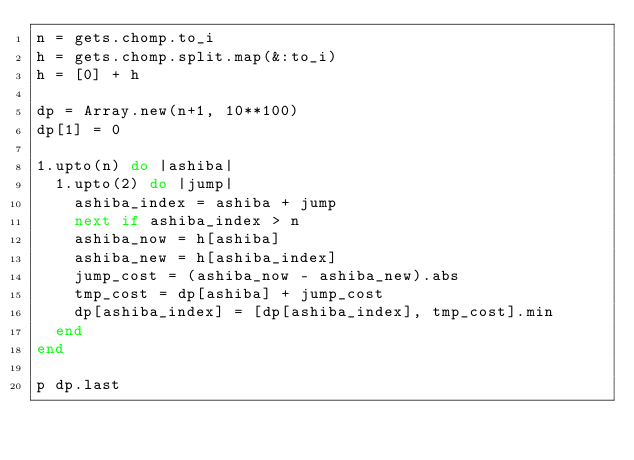Convert code to text. <code><loc_0><loc_0><loc_500><loc_500><_Ruby_>n = gets.chomp.to_i
h = gets.chomp.split.map(&:to_i)
h = [0] + h

dp = Array.new(n+1, 10**100)
dp[1] = 0

1.upto(n) do |ashiba|
  1.upto(2) do |jump|
    ashiba_index = ashiba + jump
    next if ashiba_index > n
    ashiba_now = h[ashiba]
    ashiba_new = h[ashiba_index]
    jump_cost = (ashiba_now - ashiba_new).abs
    tmp_cost = dp[ashiba] + jump_cost
    dp[ashiba_index] = [dp[ashiba_index], tmp_cost].min
  end
end

p dp.last
</code> 